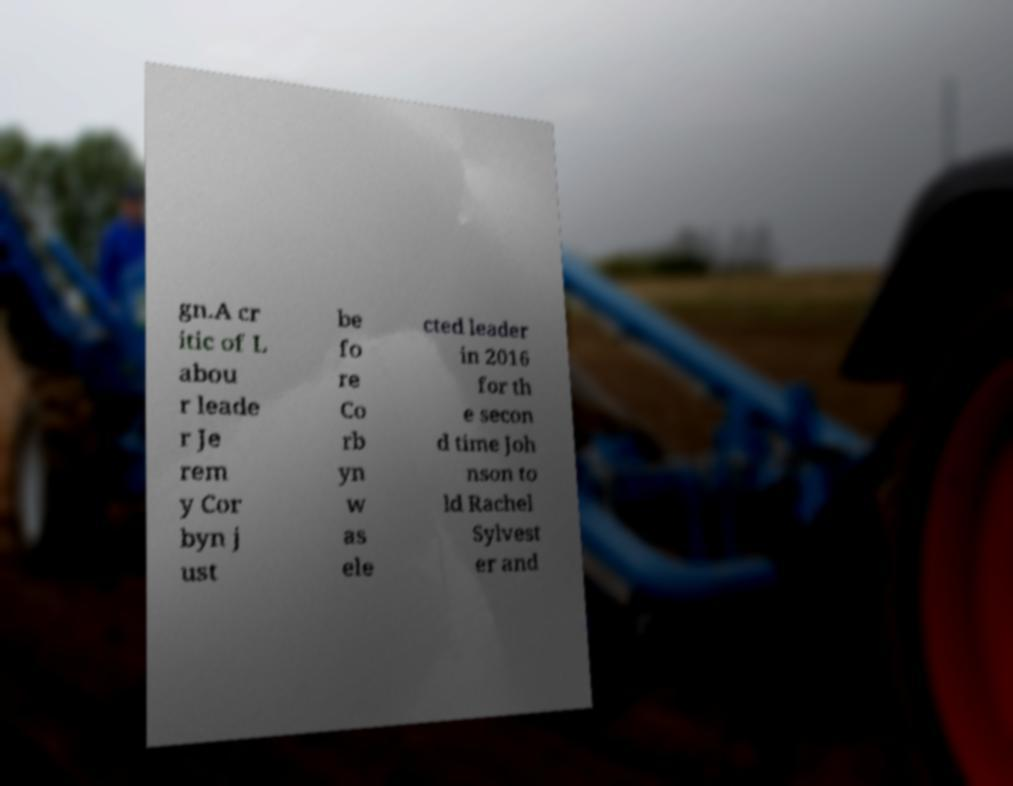Can you accurately transcribe the text from the provided image for me? gn.A cr itic of L abou r leade r Je rem y Cor byn j ust be fo re Co rb yn w as ele cted leader in 2016 for th e secon d time Joh nson to ld Rachel Sylvest er and 